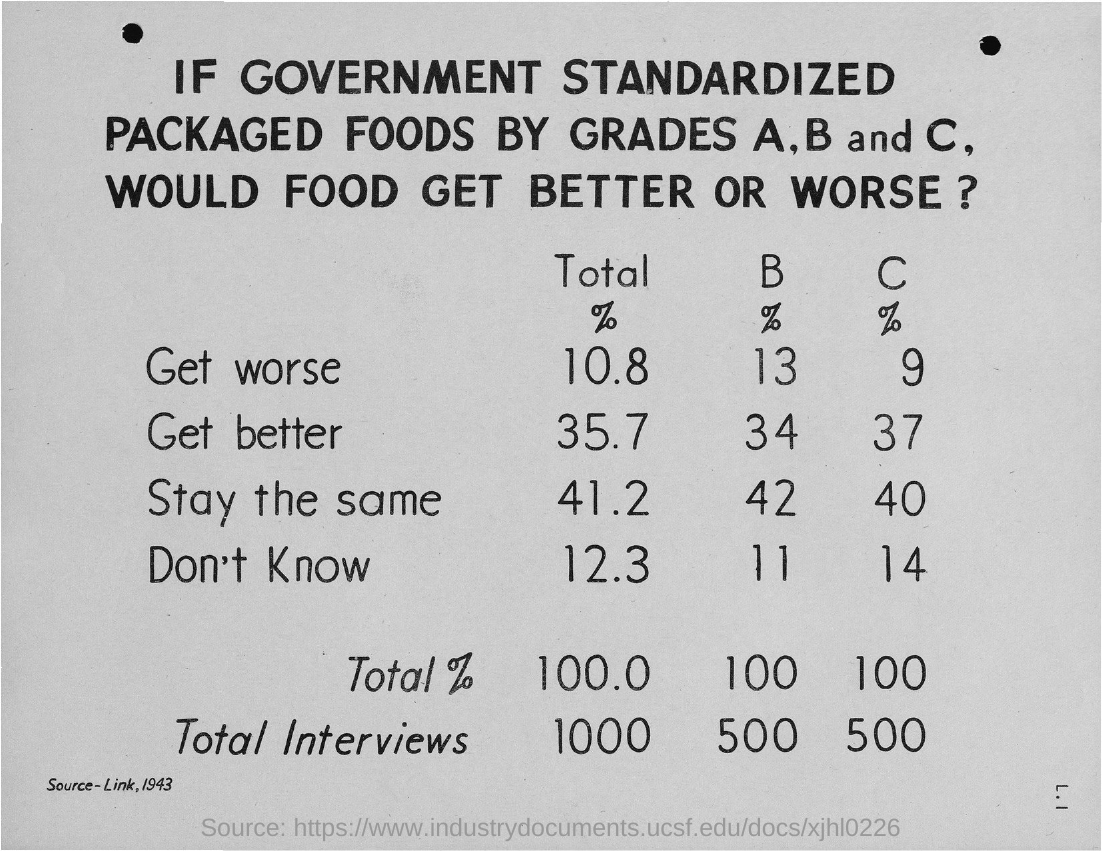What is the title of the document?
Offer a terse response. If Government standardized packaged foods by Grades A, B and C, would food get better or worse?. What is the percentage of "Don't Know" for B?
Your answer should be very brief. 11. What is the percentage of "Stay the same" for C?
Your answer should be compact. 40. What is the percentage of "Get better" for B?
Your answer should be compact. 34. 